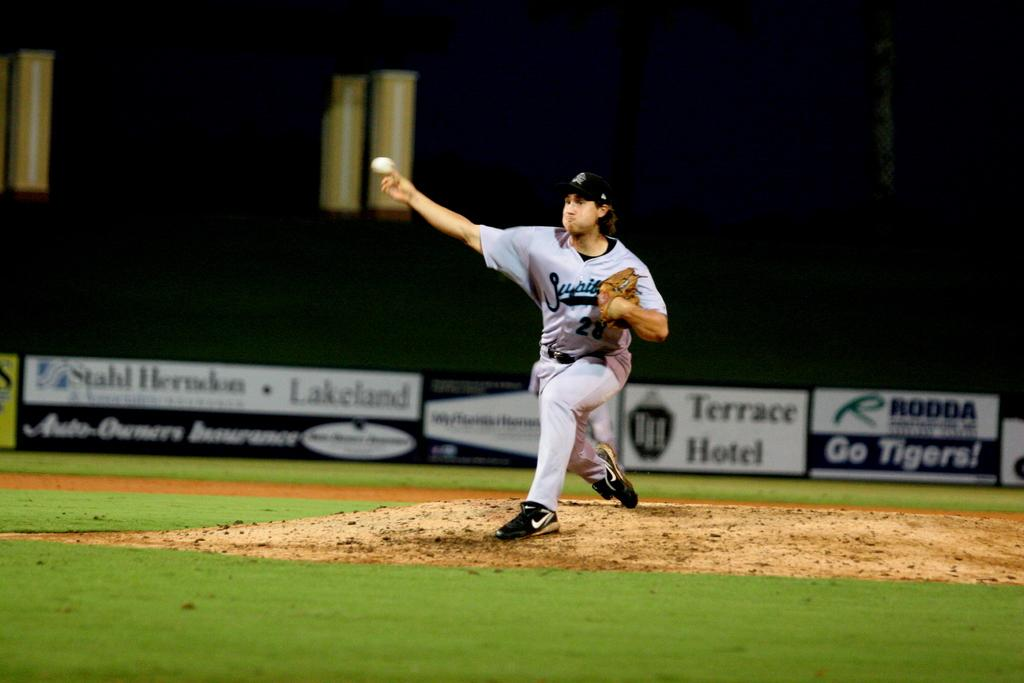<image>
Describe the image concisely. A baseball pitcher wears a uniform with the number 28 on it. 